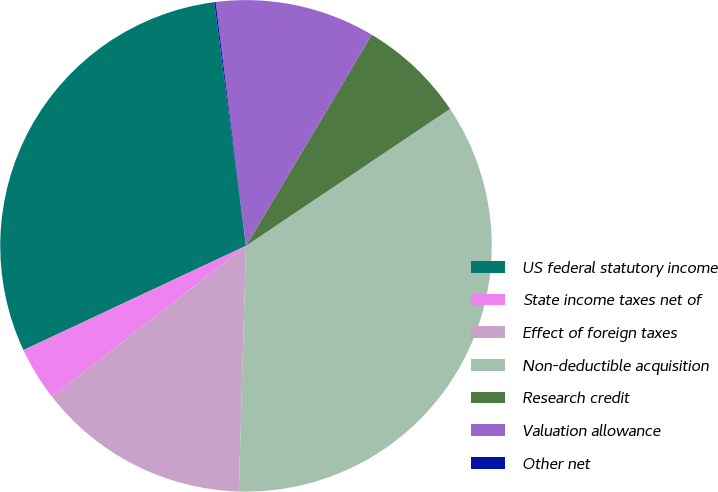Convert chart to OTSL. <chart><loc_0><loc_0><loc_500><loc_500><pie_chart><fcel>US federal statutory income<fcel>State income taxes net of<fcel>Effect of foreign taxes<fcel>Non-deductible acquisition<fcel>Research credit<fcel>Valuation allowance<fcel>Other net<nl><fcel>29.91%<fcel>3.56%<fcel>14.0%<fcel>34.87%<fcel>7.04%<fcel>10.52%<fcel>0.09%<nl></chart> 